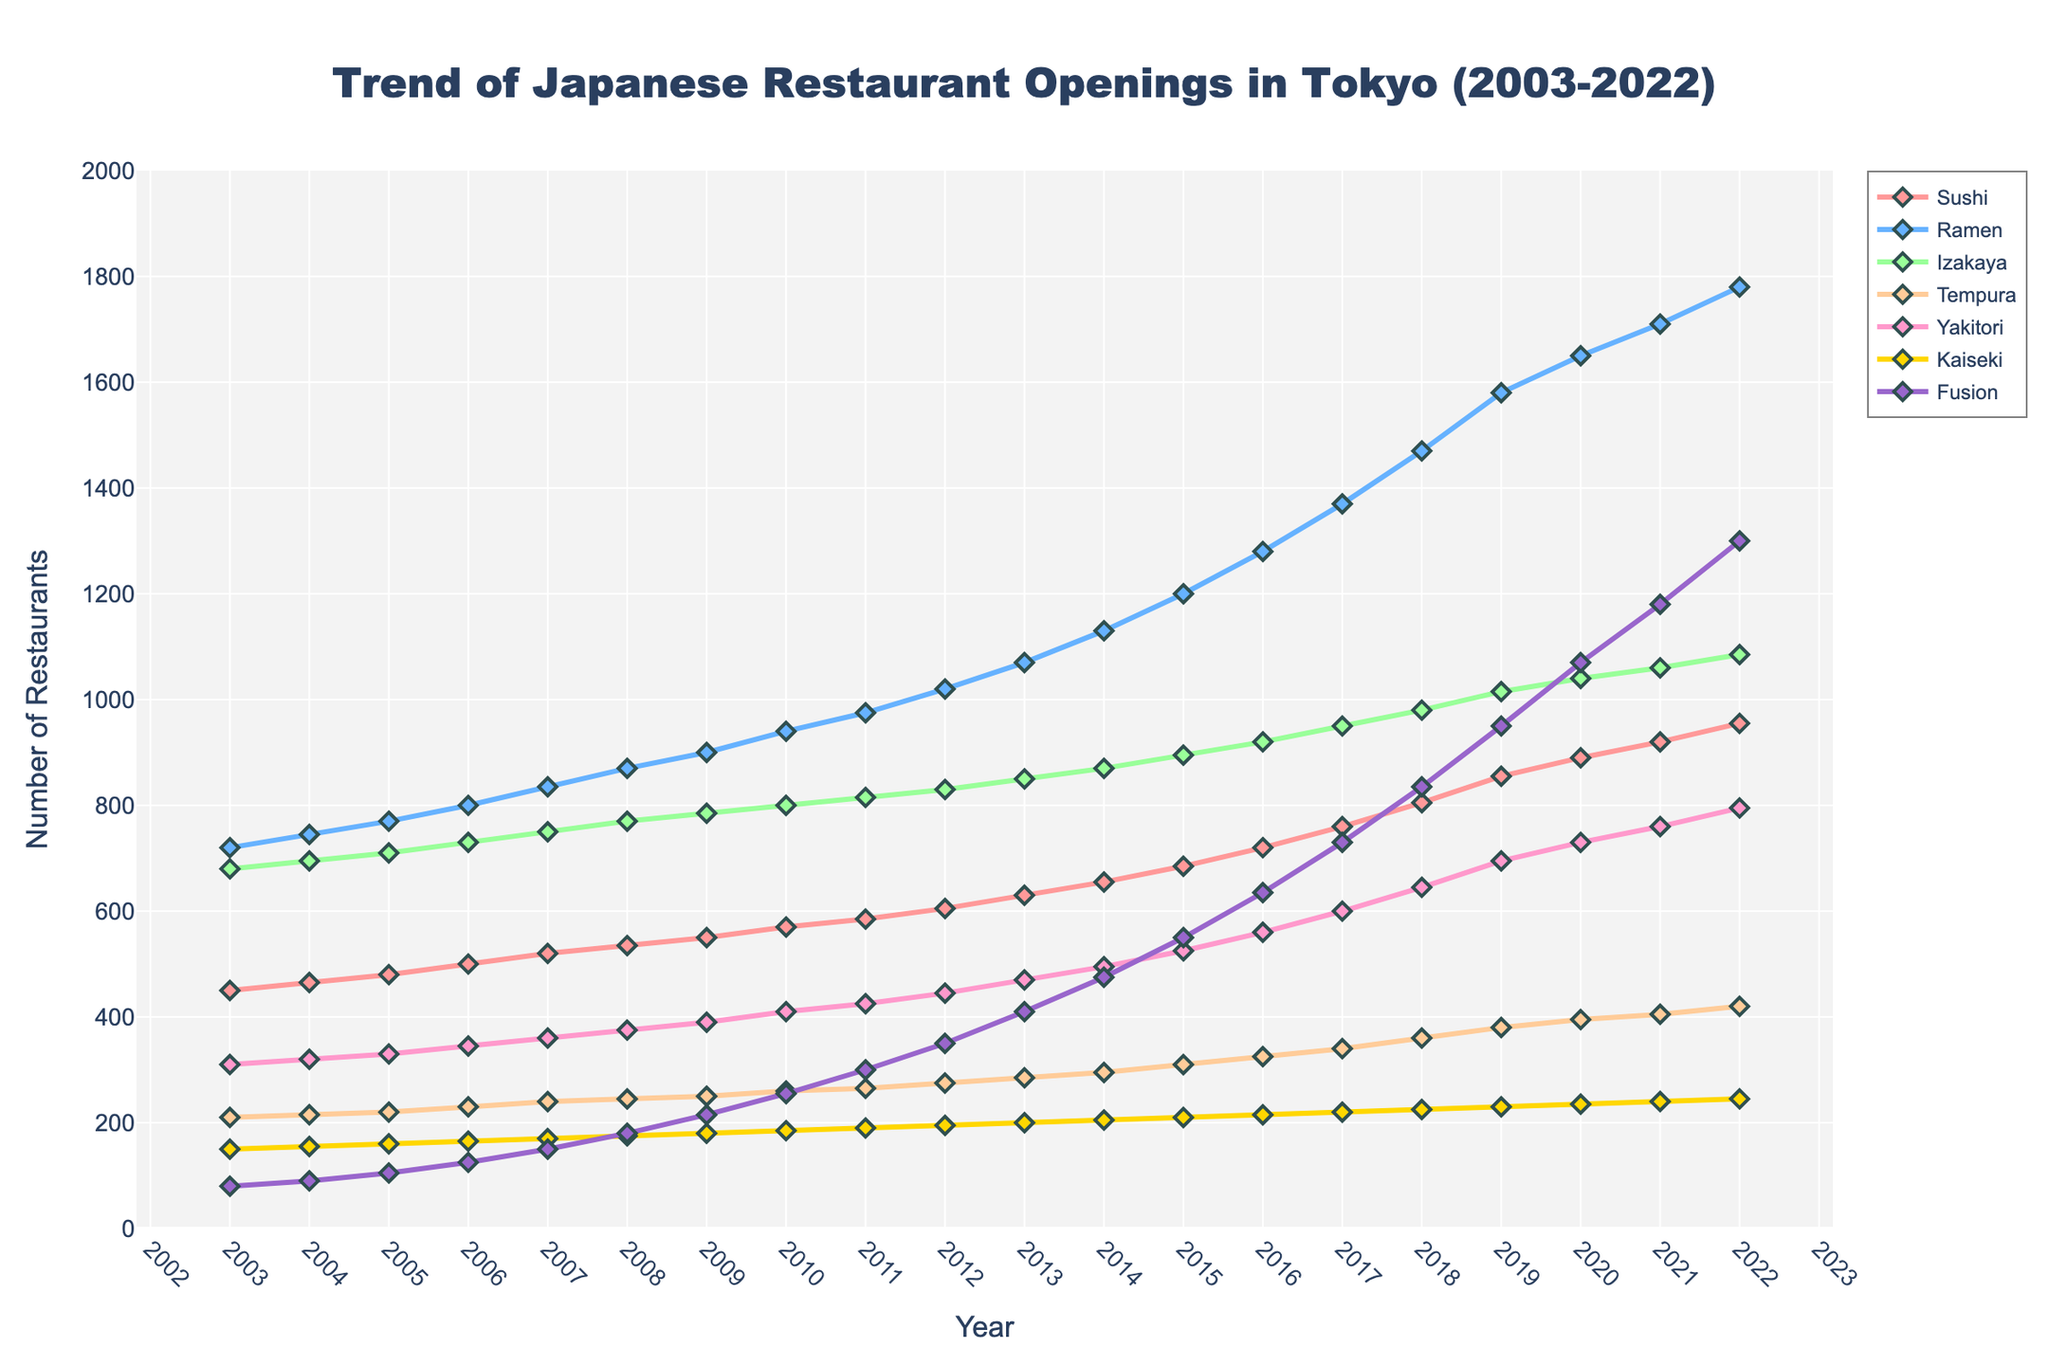Which cuisine type saw the biggest increase in the number of restaurants from 2003 to 2022? To find the answer, subtract the number of restaurants in 2003 from the number in 2022 for each cuisine. Ramen increased by 1780 - 720 = 1060, Sushi increased by 955 - 450 = 505, Izakaya increased by 1085 - 680 = 405, Tempura increased by 420 - 210 = 210, Yakitori increased by 795 - 310 = 485, Kaiseki increased by 245 - 150 = 95, and Fusion increased by 1300 - 80 = 1220. Therefore, Fusion saw the biggest increase.
Answer: Fusion During which year did Yakitori restaurants surpass 500 for the first time? Look at the line representing Yakitori and find the year when the count first exceeds 500. This happens in 2015 when there were 525 Yakitori restaurants.
Answer: 2015 By how many did Sushi restaurants increase between 2010 and 2020? Subtract the number of Sushi restaurants in 2010 from the number in 2020. Sushi in 2020 is 890, and in 2010, it is 570. The increase is 890 - 570 = 320.
Answer: 320 In which year were there exactly 215 Kaiseki restaurants? Look at the line representing Kaiseki and find the corresponding year when the count is exactly 215. This occurs in 2016.
Answer: 2016 What is the average number of Tempura restaurants over the 20-year period? Sum all the Tempura counts: 210 + 215 + 220 + 230 + 240 + 245 + 250 + 260 + 265 + 275 + 285 + 295 + 310 + 325 + 340 + 360 + 380 + 395 + 405 + 420 = 5900. Divide by 20 years to get the average: 5900 / 20 = 295.
Answer: 295 Compare the number of Izakaya with Fusion restaurants in 2012. Which was higher and by how much? Izakaya in 2012 is 830 and Fusion is 350. Subtract Fusion from Izakaya to find the difference: 830 - 350 = 480. Izakaya has more by 480.
Answer: Izakaya by 480 Which cuisine line is represented by the color green? Identify the cuisine represented by the green line in the chart. This line represents Izakaya.
Answer: Izakaya 